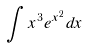Convert formula to latex. <formula><loc_0><loc_0><loc_500><loc_500>\int x ^ { 3 } e ^ { x ^ { 2 } } d x</formula> 